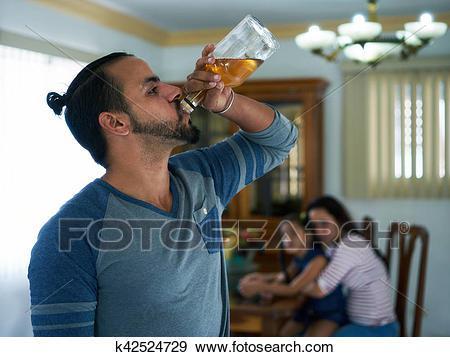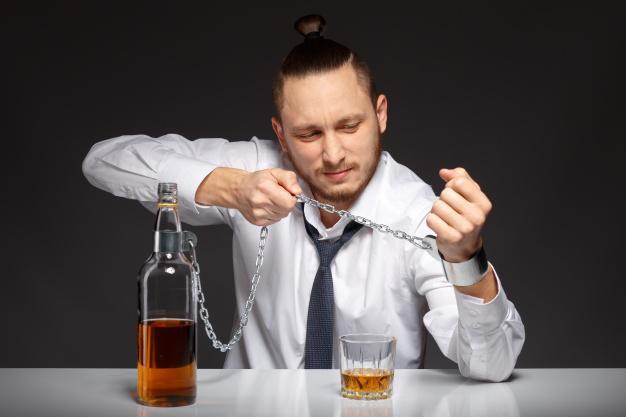The first image is the image on the left, the second image is the image on the right. Considering the images on both sides, is "The right image shows a man, sitting on a wide white chair behind bottles on a table, wearing a necktie and holding up a cardboard sign." valid? Answer yes or no. No. The first image is the image on the left, the second image is the image on the right. Considering the images on both sides, is "The left and right image contains the same number of identical men in the same shirts.." valid? Answer yes or no. No. 